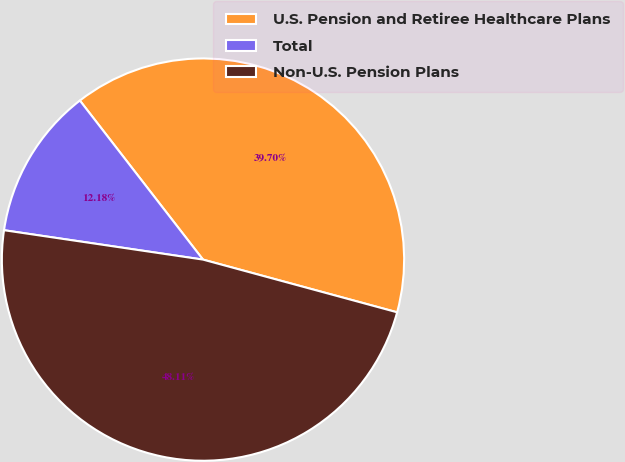Convert chart. <chart><loc_0><loc_0><loc_500><loc_500><pie_chart><fcel>U.S. Pension and Retiree Healthcare Plans<fcel>Total<fcel>Non-U.S. Pension Plans<nl><fcel>39.7%<fcel>12.18%<fcel>48.11%<nl></chart> 